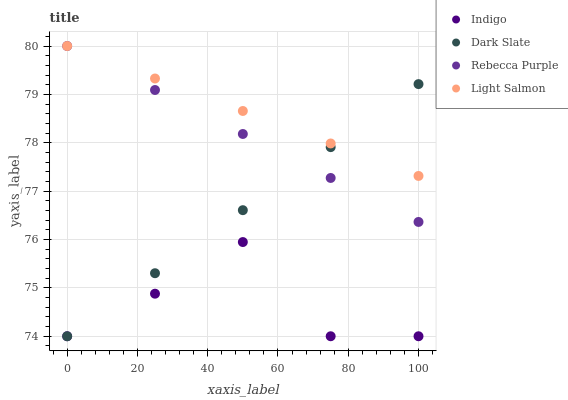Does Indigo have the minimum area under the curve?
Answer yes or no. Yes. Does Light Salmon have the maximum area under the curve?
Answer yes or no. Yes. Does Light Salmon have the minimum area under the curve?
Answer yes or no. No. Does Indigo have the maximum area under the curve?
Answer yes or no. No. Is Dark Slate the smoothest?
Answer yes or no. Yes. Is Indigo the roughest?
Answer yes or no. Yes. Is Indigo the smoothest?
Answer yes or no. No. Is Light Salmon the roughest?
Answer yes or no. No. Does Dark Slate have the lowest value?
Answer yes or no. Yes. Does Light Salmon have the lowest value?
Answer yes or no. No. Does Rebecca Purple have the highest value?
Answer yes or no. Yes. Does Indigo have the highest value?
Answer yes or no. No. Is Indigo less than Rebecca Purple?
Answer yes or no. Yes. Is Rebecca Purple greater than Indigo?
Answer yes or no. Yes. Does Rebecca Purple intersect Light Salmon?
Answer yes or no. Yes. Is Rebecca Purple less than Light Salmon?
Answer yes or no. No. Is Rebecca Purple greater than Light Salmon?
Answer yes or no. No. Does Indigo intersect Rebecca Purple?
Answer yes or no. No. 